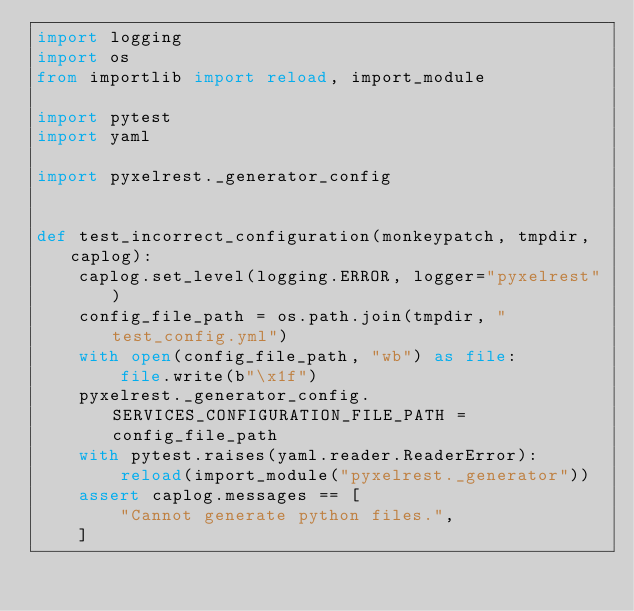Convert code to text. <code><loc_0><loc_0><loc_500><loc_500><_Python_>import logging
import os
from importlib import reload, import_module

import pytest
import yaml

import pyxelrest._generator_config


def test_incorrect_configuration(monkeypatch, tmpdir, caplog):
    caplog.set_level(logging.ERROR, logger="pyxelrest")
    config_file_path = os.path.join(tmpdir, "test_config.yml")
    with open(config_file_path, "wb") as file:
        file.write(b"\x1f")
    pyxelrest._generator_config.SERVICES_CONFIGURATION_FILE_PATH = config_file_path
    with pytest.raises(yaml.reader.ReaderError):
        reload(import_module("pyxelrest._generator"))
    assert caplog.messages == [
        "Cannot generate python files.",
    ]
</code> 